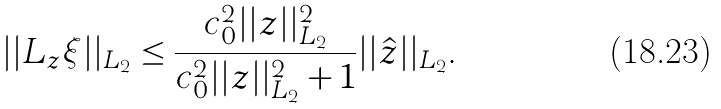<formula> <loc_0><loc_0><loc_500><loc_500>| | L _ { z } \xi | | _ { L _ { 2 } } \leq \frac { c _ { 0 } ^ { 2 } | | z | | _ { L _ { 2 } } ^ { 2 } } { c _ { 0 } ^ { 2 } | | z | | _ { L _ { 2 } } ^ { 2 } + 1 } | | \hat { z } | | _ { L _ { 2 } } .</formula> 